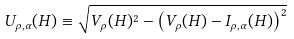Convert formula to latex. <formula><loc_0><loc_0><loc_500><loc_500>U _ { \rho , \alpha } ( H ) \equiv \sqrt { V _ { \rho } ( H ) ^ { 2 } - \left ( V _ { \rho } ( H ) - I _ { \rho , \alpha } ( H ) \right ) ^ { 2 } }</formula> 